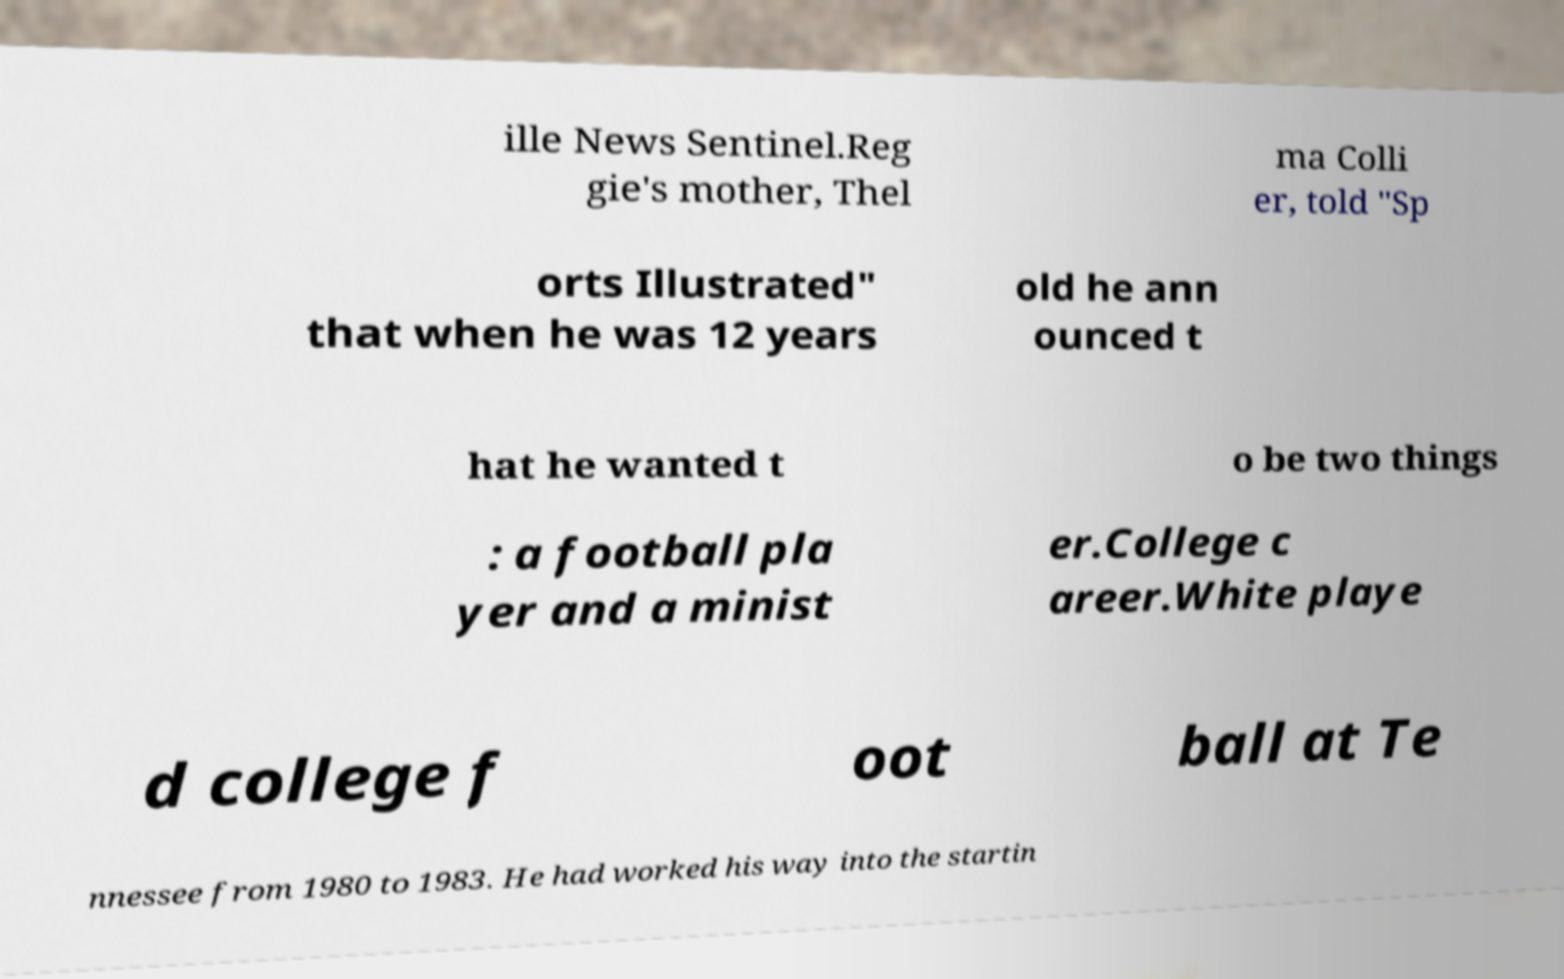Can you read and provide the text displayed in the image?This photo seems to have some interesting text. Can you extract and type it out for me? ille News Sentinel.Reg gie's mother, Thel ma Colli er, told "Sp orts Illustrated" that when he was 12 years old he ann ounced t hat he wanted t o be two things : a football pla yer and a minist er.College c areer.White playe d college f oot ball at Te nnessee from 1980 to 1983. He had worked his way into the startin 